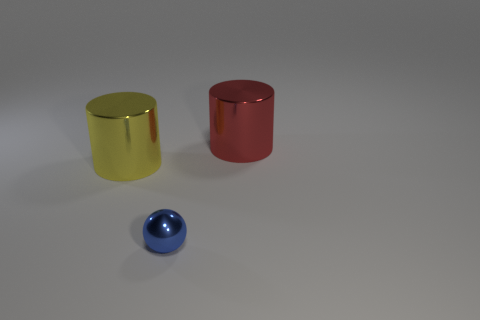The blue metal object is what size?
Offer a terse response. Small. Are there more metal cylinders to the right of the small object than blue metallic balls left of the yellow shiny cylinder?
Ensure brevity in your answer.  Yes. There is a small blue thing; are there any metallic cylinders to the left of it?
Offer a terse response. Yes. Are there any brown rubber balls that have the same size as the red metal cylinder?
Ensure brevity in your answer.  No. The cylinder that is the same material as the big red object is what color?
Keep it short and to the point. Yellow. What material is the blue ball?
Provide a short and direct response. Metal. What is the shape of the large red thing?
Your answer should be very brief. Cylinder. How many blue objects are large metallic cylinders or balls?
Provide a short and direct response. 1. What is the size of the blue sphere that is on the left side of the cylinder that is to the right of the large shiny object that is to the left of the ball?
Give a very brief answer. Small. The other metallic object that is the same shape as the red thing is what size?
Offer a terse response. Large. 